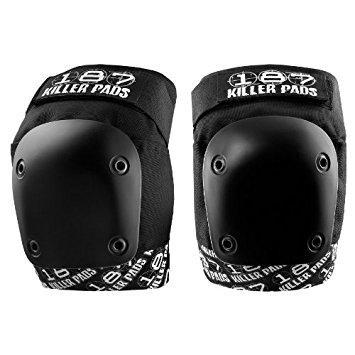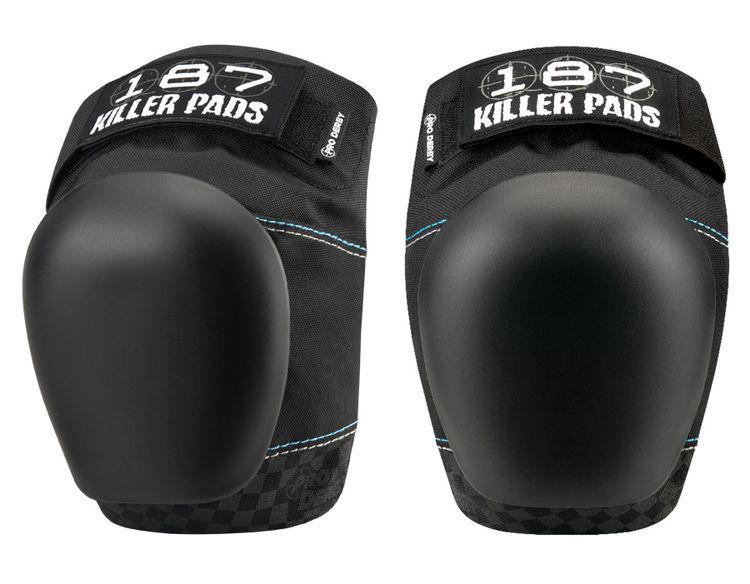The first image is the image on the left, the second image is the image on the right. Examine the images to the left and right. Is the description "Each image contains a pair of black knee pads, and one image features a pair of knee pads with black and white print on the tops and bottoms." accurate? Answer yes or no. Yes. The first image is the image on the left, the second image is the image on the right. Examine the images to the left and right. Is the description "One pair of pads has visible red tags, and the other pair does not." accurate? Answer yes or no. No. 